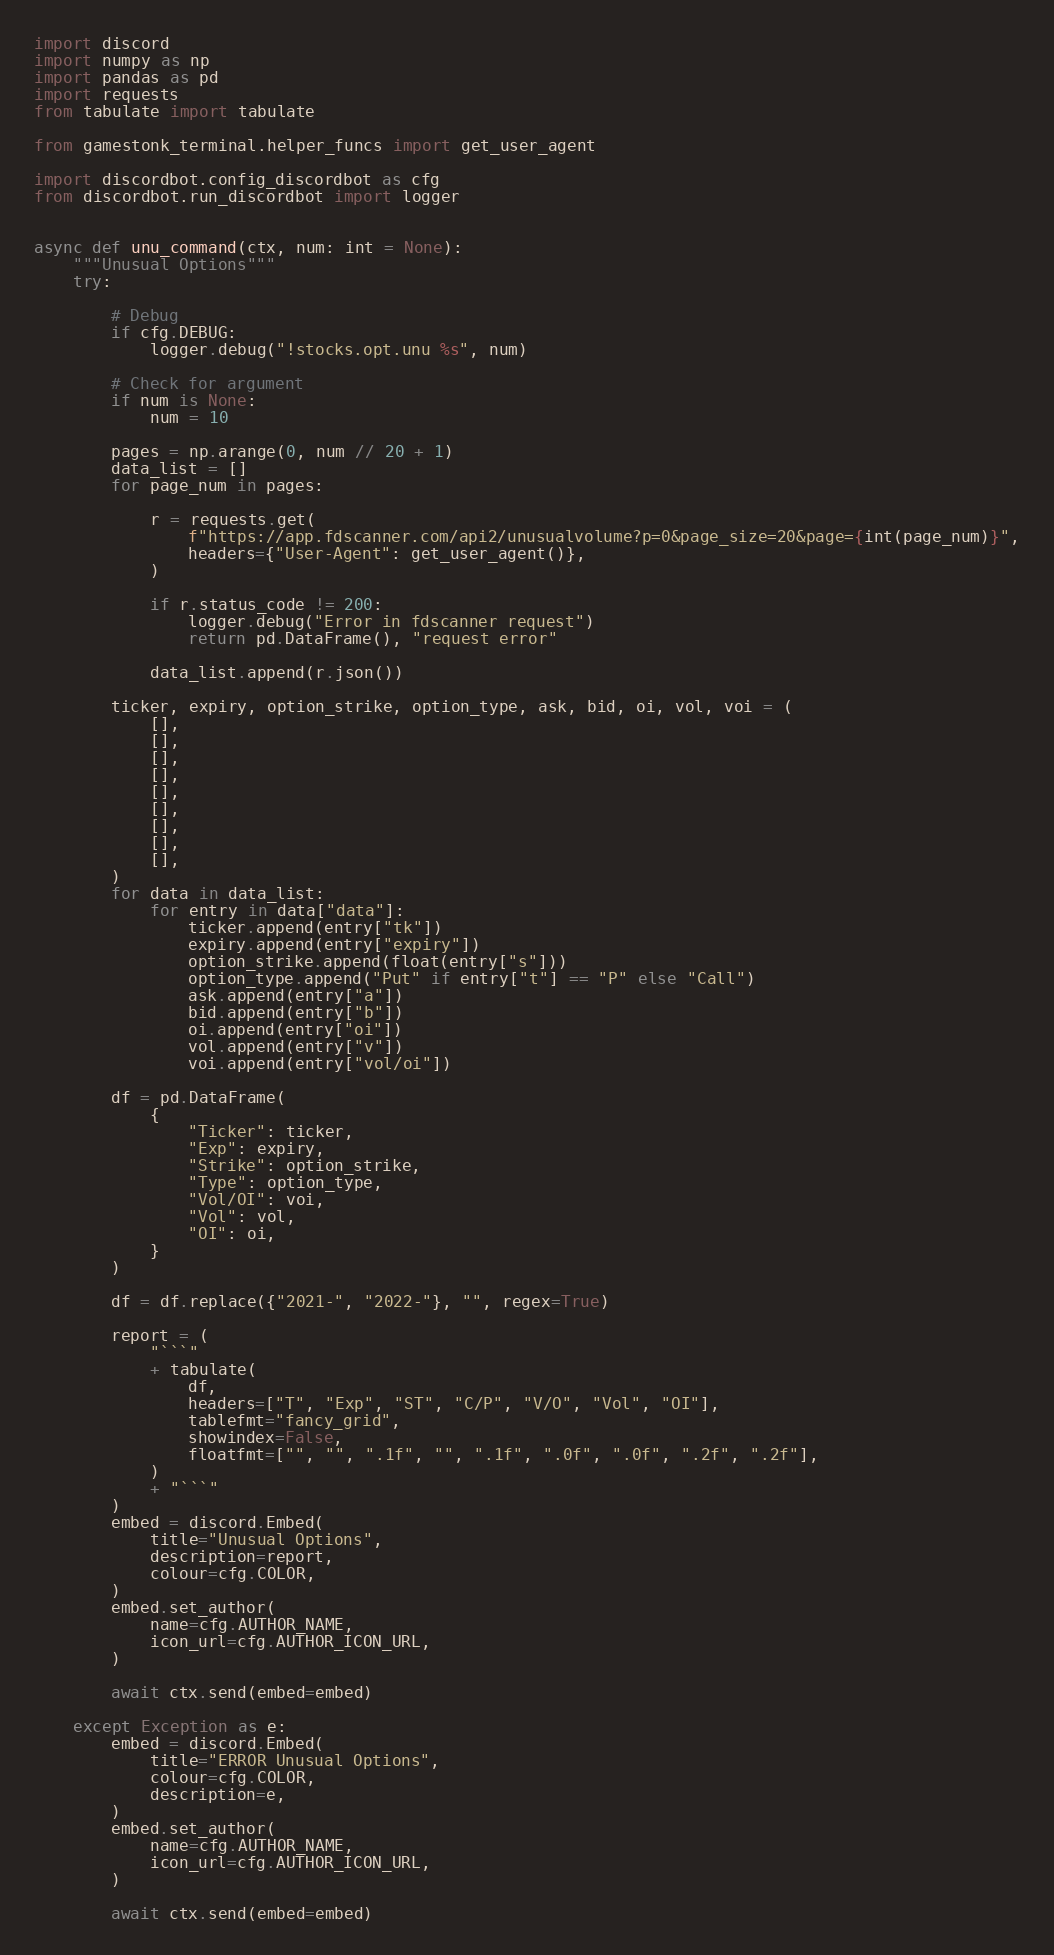Convert code to text. <code><loc_0><loc_0><loc_500><loc_500><_Python_>import discord
import numpy as np
import pandas as pd
import requests
from tabulate import tabulate

from gamestonk_terminal.helper_funcs import get_user_agent

import discordbot.config_discordbot as cfg
from discordbot.run_discordbot import logger


async def unu_command(ctx, num: int = None):
    """Unusual Options"""
    try:

        # Debug
        if cfg.DEBUG:
            logger.debug("!stocks.opt.unu %s", num)

        # Check for argument
        if num is None:
            num = 10

        pages = np.arange(0, num // 20 + 1)
        data_list = []
        for page_num in pages:

            r = requests.get(
                f"https://app.fdscanner.com/api2/unusualvolume?p=0&page_size=20&page={int(page_num)}",
                headers={"User-Agent": get_user_agent()},
            )

            if r.status_code != 200:
                logger.debug("Error in fdscanner request")
                return pd.DataFrame(), "request error"

            data_list.append(r.json())

        ticker, expiry, option_strike, option_type, ask, bid, oi, vol, voi = (
            [],
            [],
            [],
            [],
            [],
            [],
            [],
            [],
            [],
        )
        for data in data_list:
            for entry in data["data"]:
                ticker.append(entry["tk"])
                expiry.append(entry["expiry"])
                option_strike.append(float(entry["s"]))
                option_type.append("Put" if entry["t"] == "P" else "Call")
                ask.append(entry["a"])
                bid.append(entry["b"])
                oi.append(entry["oi"])
                vol.append(entry["v"])
                voi.append(entry["vol/oi"])

        df = pd.DataFrame(
            {
                "Ticker": ticker,
                "Exp": expiry,
                "Strike": option_strike,
                "Type": option_type,
                "Vol/OI": voi,
                "Vol": vol,
                "OI": oi,
            }
        )

        df = df.replace({"2021-", "2022-"}, "", regex=True)

        report = (
            "```"
            + tabulate(
                df,
                headers=["T", "Exp", "ST", "C/P", "V/O", "Vol", "OI"],
                tablefmt="fancy_grid",
                showindex=False,
                floatfmt=["", "", ".1f", "", ".1f", ".0f", ".0f", ".2f", ".2f"],
            )
            + "```"
        )
        embed = discord.Embed(
            title="Unusual Options",
            description=report,
            colour=cfg.COLOR,
        )
        embed.set_author(
            name=cfg.AUTHOR_NAME,
            icon_url=cfg.AUTHOR_ICON_URL,
        )

        await ctx.send(embed=embed)

    except Exception as e:
        embed = discord.Embed(
            title="ERROR Unusual Options",
            colour=cfg.COLOR,
            description=e,
        )
        embed.set_author(
            name=cfg.AUTHOR_NAME,
            icon_url=cfg.AUTHOR_ICON_URL,
        )

        await ctx.send(embed=embed)
</code> 